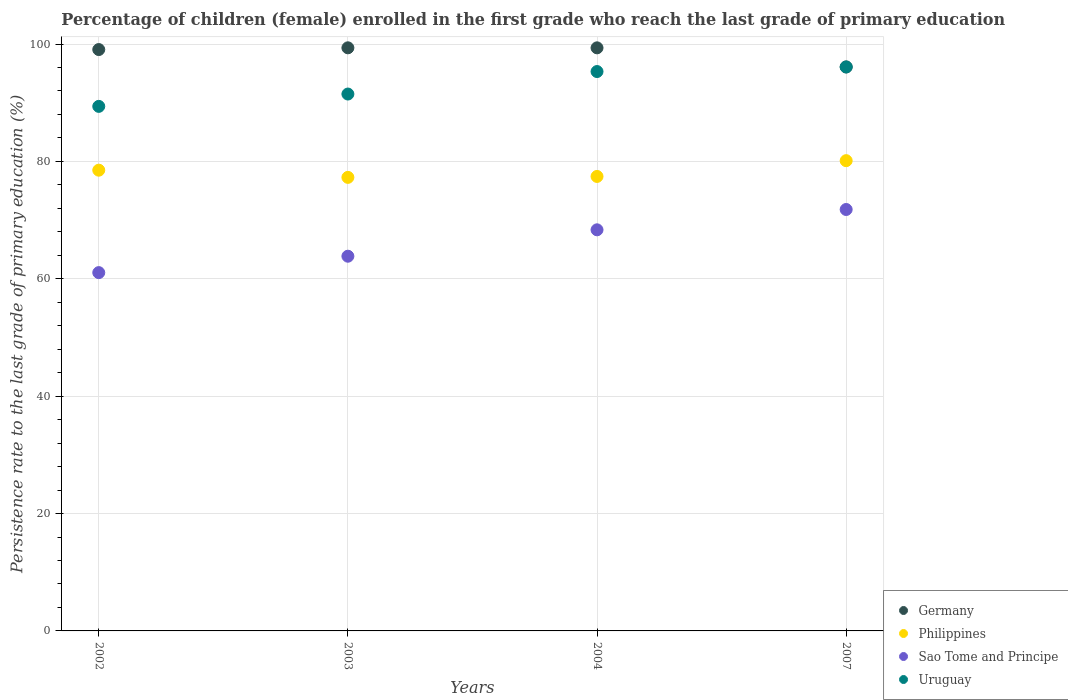What is the persistence rate of children in Germany in 2003?
Make the answer very short. 99.35. Across all years, what is the maximum persistence rate of children in Sao Tome and Principe?
Your response must be concise. 71.8. Across all years, what is the minimum persistence rate of children in Philippines?
Ensure brevity in your answer.  77.28. In which year was the persistence rate of children in Germany maximum?
Provide a short and direct response. 2003. What is the total persistence rate of children in Germany in the graph?
Your response must be concise. 393.84. What is the difference between the persistence rate of children in Sao Tome and Principe in 2002 and that in 2003?
Ensure brevity in your answer.  -2.8. What is the difference between the persistence rate of children in Sao Tome and Principe in 2003 and the persistence rate of children in Germany in 2007?
Your response must be concise. -32.24. What is the average persistence rate of children in Philippines per year?
Ensure brevity in your answer.  78.33. In the year 2004, what is the difference between the persistence rate of children in Philippines and persistence rate of children in Uruguay?
Keep it short and to the point. -17.87. What is the ratio of the persistence rate of children in Sao Tome and Principe in 2002 to that in 2003?
Provide a short and direct response. 0.96. Is the persistence rate of children in Sao Tome and Principe in 2002 less than that in 2007?
Offer a very short reply. Yes. Is the difference between the persistence rate of children in Philippines in 2002 and 2003 greater than the difference between the persistence rate of children in Uruguay in 2002 and 2003?
Your answer should be very brief. Yes. What is the difference between the highest and the second highest persistence rate of children in Germany?
Ensure brevity in your answer.  0. What is the difference between the highest and the lowest persistence rate of children in Uruguay?
Keep it short and to the point. 6.72. Is it the case that in every year, the sum of the persistence rate of children in Germany and persistence rate of children in Uruguay  is greater than the persistence rate of children in Sao Tome and Principe?
Offer a very short reply. Yes. Is the persistence rate of children in Uruguay strictly greater than the persistence rate of children in Germany over the years?
Ensure brevity in your answer.  No. How many years are there in the graph?
Provide a short and direct response. 4. What is the difference between two consecutive major ticks on the Y-axis?
Ensure brevity in your answer.  20. Does the graph contain grids?
Offer a very short reply. Yes. How many legend labels are there?
Offer a terse response. 4. What is the title of the graph?
Offer a terse response. Percentage of children (female) enrolled in the first grade who reach the last grade of primary education. What is the label or title of the X-axis?
Provide a short and direct response. Years. What is the label or title of the Y-axis?
Make the answer very short. Persistence rate to the last grade of primary education (%). What is the Persistence rate to the last grade of primary education (%) in Germany in 2002?
Make the answer very short. 99.05. What is the Persistence rate to the last grade of primary education (%) of Philippines in 2002?
Provide a succinct answer. 78.5. What is the Persistence rate to the last grade of primary education (%) in Sao Tome and Principe in 2002?
Your answer should be very brief. 61.05. What is the Persistence rate to the last grade of primary education (%) in Uruguay in 2002?
Keep it short and to the point. 89.37. What is the Persistence rate to the last grade of primary education (%) of Germany in 2003?
Ensure brevity in your answer.  99.35. What is the Persistence rate to the last grade of primary education (%) in Philippines in 2003?
Offer a terse response. 77.28. What is the Persistence rate to the last grade of primary education (%) of Sao Tome and Principe in 2003?
Offer a very short reply. 63.84. What is the Persistence rate to the last grade of primary education (%) of Uruguay in 2003?
Provide a short and direct response. 91.48. What is the Persistence rate to the last grade of primary education (%) of Germany in 2004?
Keep it short and to the point. 99.35. What is the Persistence rate to the last grade of primary education (%) in Philippines in 2004?
Offer a terse response. 77.44. What is the Persistence rate to the last grade of primary education (%) in Sao Tome and Principe in 2004?
Keep it short and to the point. 68.34. What is the Persistence rate to the last grade of primary education (%) in Uruguay in 2004?
Provide a short and direct response. 95.31. What is the Persistence rate to the last grade of primary education (%) in Germany in 2007?
Ensure brevity in your answer.  96.09. What is the Persistence rate to the last grade of primary education (%) in Philippines in 2007?
Provide a short and direct response. 80.12. What is the Persistence rate to the last grade of primary education (%) of Sao Tome and Principe in 2007?
Give a very brief answer. 71.8. What is the Persistence rate to the last grade of primary education (%) of Uruguay in 2007?
Keep it short and to the point. 96.09. Across all years, what is the maximum Persistence rate to the last grade of primary education (%) of Germany?
Your answer should be very brief. 99.35. Across all years, what is the maximum Persistence rate to the last grade of primary education (%) in Philippines?
Your answer should be compact. 80.12. Across all years, what is the maximum Persistence rate to the last grade of primary education (%) in Sao Tome and Principe?
Provide a succinct answer. 71.8. Across all years, what is the maximum Persistence rate to the last grade of primary education (%) in Uruguay?
Keep it short and to the point. 96.09. Across all years, what is the minimum Persistence rate to the last grade of primary education (%) of Germany?
Your answer should be compact. 96.09. Across all years, what is the minimum Persistence rate to the last grade of primary education (%) in Philippines?
Your answer should be compact. 77.28. Across all years, what is the minimum Persistence rate to the last grade of primary education (%) in Sao Tome and Principe?
Offer a terse response. 61.05. Across all years, what is the minimum Persistence rate to the last grade of primary education (%) in Uruguay?
Your answer should be very brief. 89.37. What is the total Persistence rate to the last grade of primary education (%) in Germany in the graph?
Offer a terse response. 393.84. What is the total Persistence rate to the last grade of primary education (%) of Philippines in the graph?
Your response must be concise. 313.34. What is the total Persistence rate to the last grade of primary education (%) in Sao Tome and Principe in the graph?
Ensure brevity in your answer.  265.04. What is the total Persistence rate to the last grade of primary education (%) of Uruguay in the graph?
Offer a terse response. 372.25. What is the difference between the Persistence rate to the last grade of primary education (%) of Germany in 2002 and that in 2003?
Your answer should be very brief. -0.3. What is the difference between the Persistence rate to the last grade of primary education (%) in Philippines in 2002 and that in 2003?
Your answer should be very brief. 1.23. What is the difference between the Persistence rate to the last grade of primary education (%) of Sao Tome and Principe in 2002 and that in 2003?
Offer a terse response. -2.8. What is the difference between the Persistence rate to the last grade of primary education (%) in Uruguay in 2002 and that in 2003?
Give a very brief answer. -2.1. What is the difference between the Persistence rate to the last grade of primary education (%) in Germany in 2002 and that in 2004?
Provide a short and direct response. -0.29. What is the difference between the Persistence rate to the last grade of primary education (%) of Philippines in 2002 and that in 2004?
Provide a succinct answer. 1.07. What is the difference between the Persistence rate to the last grade of primary education (%) of Sao Tome and Principe in 2002 and that in 2004?
Your response must be concise. -7.29. What is the difference between the Persistence rate to the last grade of primary education (%) in Uruguay in 2002 and that in 2004?
Provide a succinct answer. -5.93. What is the difference between the Persistence rate to the last grade of primary education (%) of Germany in 2002 and that in 2007?
Provide a succinct answer. 2.97. What is the difference between the Persistence rate to the last grade of primary education (%) of Philippines in 2002 and that in 2007?
Keep it short and to the point. -1.62. What is the difference between the Persistence rate to the last grade of primary education (%) of Sao Tome and Principe in 2002 and that in 2007?
Offer a very short reply. -10.76. What is the difference between the Persistence rate to the last grade of primary education (%) in Uruguay in 2002 and that in 2007?
Your answer should be very brief. -6.72. What is the difference between the Persistence rate to the last grade of primary education (%) of Germany in 2003 and that in 2004?
Your response must be concise. 0. What is the difference between the Persistence rate to the last grade of primary education (%) in Philippines in 2003 and that in 2004?
Make the answer very short. -0.16. What is the difference between the Persistence rate to the last grade of primary education (%) of Sao Tome and Principe in 2003 and that in 2004?
Ensure brevity in your answer.  -4.5. What is the difference between the Persistence rate to the last grade of primary education (%) of Uruguay in 2003 and that in 2004?
Offer a terse response. -3.83. What is the difference between the Persistence rate to the last grade of primary education (%) in Germany in 2003 and that in 2007?
Make the answer very short. 3.26. What is the difference between the Persistence rate to the last grade of primary education (%) in Philippines in 2003 and that in 2007?
Keep it short and to the point. -2.85. What is the difference between the Persistence rate to the last grade of primary education (%) in Sao Tome and Principe in 2003 and that in 2007?
Ensure brevity in your answer.  -7.96. What is the difference between the Persistence rate to the last grade of primary education (%) in Uruguay in 2003 and that in 2007?
Give a very brief answer. -4.62. What is the difference between the Persistence rate to the last grade of primary education (%) in Germany in 2004 and that in 2007?
Provide a succinct answer. 3.26. What is the difference between the Persistence rate to the last grade of primary education (%) in Philippines in 2004 and that in 2007?
Your answer should be very brief. -2.69. What is the difference between the Persistence rate to the last grade of primary education (%) of Sao Tome and Principe in 2004 and that in 2007?
Offer a very short reply. -3.46. What is the difference between the Persistence rate to the last grade of primary education (%) of Uruguay in 2004 and that in 2007?
Provide a succinct answer. -0.78. What is the difference between the Persistence rate to the last grade of primary education (%) of Germany in 2002 and the Persistence rate to the last grade of primary education (%) of Philippines in 2003?
Your answer should be compact. 21.78. What is the difference between the Persistence rate to the last grade of primary education (%) in Germany in 2002 and the Persistence rate to the last grade of primary education (%) in Sao Tome and Principe in 2003?
Make the answer very short. 35.21. What is the difference between the Persistence rate to the last grade of primary education (%) in Germany in 2002 and the Persistence rate to the last grade of primary education (%) in Uruguay in 2003?
Make the answer very short. 7.58. What is the difference between the Persistence rate to the last grade of primary education (%) of Philippines in 2002 and the Persistence rate to the last grade of primary education (%) of Sao Tome and Principe in 2003?
Keep it short and to the point. 14.66. What is the difference between the Persistence rate to the last grade of primary education (%) in Philippines in 2002 and the Persistence rate to the last grade of primary education (%) in Uruguay in 2003?
Keep it short and to the point. -12.97. What is the difference between the Persistence rate to the last grade of primary education (%) in Sao Tome and Principe in 2002 and the Persistence rate to the last grade of primary education (%) in Uruguay in 2003?
Make the answer very short. -30.43. What is the difference between the Persistence rate to the last grade of primary education (%) in Germany in 2002 and the Persistence rate to the last grade of primary education (%) in Philippines in 2004?
Your answer should be very brief. 21.62. What is the difference between the Persistence rate to the last grade of primary education (%) of Germany in 2002 and the Persistence rate to the last grade of primary education (%) of Sao Tome and Principe in 2004?
Offer a terse response. 30.71. What is the difference between the Persistence rate to the last grade of primary education (%) of Germany in 2002 and the Persistence rate to the last grade of primary education (%) of Uruguay in 2004?
Provide a succinct answer. 3.75. What is the difference between the Persistence rate to the last grade of primary education (%) of Philippines in 2002 and the Persistence rate to the last grade of primary education (%) of Sao Tome and Principe in 2004?
Provide a succinct answer. 10.16. What is the difference between the Persistence rate to the last grade of primary education (%) of Philippines in 2002 and the Persistence rate to the last grade of primary education (%) of Uruguay in 2004?
Provide a short and direct response. -16.81. What is the difference between the Persistence rate to the last grade of primary education (%) of Sao Tome and Principe in 2002 and the Persistence rate to the last grade of primary education (%) of Uruguay in 2004?
Ensure brevity in your answer.  -34.26. What is the difference between the Persistence rate to the last grade of primary education (%) in Germany in 2002 and the Persistence rate to the last grade of primary education (%) in Philippines in 2007?
Give a very brief answer. 18.93. What is the difference between the Persistence rate to the last grade of primary education (%) in Germany in 2002 and the Persistence rate to the last grade of primary education (%) in Sao Tome and Principe in 2007?
Your answer should be compact. 27.25. What is the difference between the Persistence rate to the last grade of primary education (%) in Germany in 2002 and the Persistence rate to the last grade of primary education (%) in Uruguay in 2007?
Ensure brevity in your answer.  2.96. What is the difference between the Persistence rate to the last grade of primary education (%) of Philippines in 2002 and the Persistence rate to the last grade of primary education (%) of Sao Tome and Principe in 2007?
Ensure brevity in your answer.  6.7. What is the difference between the Persistence rate to the last grade of primary education (%) in Philippines in 2002 and the Persistence rate to the last grade of primary education (%) in Uruguay in 2007?
Give a very brief answer. -17.59. What is the difference between the Persistence rate to the last grade of primary education (%) of Sao Tome and Principe in 2002 and the Persistence rate to the last grade of primary education (%) of Uruguay in 2007?
Provide a short and direct response. -35.04. What is the difference between the Persistence rate to the last grade of primary education (%) of Germany in 2003 and the Persistence rate to the last grade of primary education (%) of Philippines in 2004?
Provide a succinct answer. 21.92. What is the difference between the Persistence rate to the last grade of primary education (%) of Germany in 2003 and the Persistence rate to the last grade of primary education (%) of Sao Tome and Principe in 2004?
Your response must be concise. 31.01. What is the difference between the Persistence rate to the last grade of primary education (%) in Germany in 2003 and the Persistence rate to the last grade of primary education (%) in Uruguay in 2004?
Give a very brief answer. 4.04. What is the difference between the Persistence rate to the last grade of primary education (%) in Philippines in 2003 and the Persistence rate to the last grade of primary education (%) in Sao Tome and Principe in 2004?
Offer a terse response. 8.94. What is the difference between the Persistence rate to the last grade of primary education (%) of Philippines in 2003 and the Persistence rate to the last grade of primary education (%) of Uruguay in 2004?
Your answer should be very brief. -18.03. What is the difference between the Persistence rate to the last grade of primary education (%) in Sao Tome and Principe in 2003 and the Persistence rate to the last grade of primary education (%) in Uruguay in 2004?
Give a very brief answer. -31.46. What is the difference between the Persistence rate to the last grade of primary education (%) in Germany in 2003 and the Persistence rate to the last grade of primary education (%) in Philippines in 2007?
Give a very brief answer. 19.23. What is the difference between the Persistence rate to the last grade of primary education (%) of Germany in 2003 and the Persistence rate to the last grade of primary education (%) of Sao Tome and Principe in 2007?
Make the answer very short. 27.55. What is the difference between the Persistence rate to the last grade of primary education (%) of Germany in 2003 and the Persistence rate to the last grade of primary education (%) of Uruguay in 2007?
Your answer should be compact. 3.26. What is the difference between the Persistence rate to the last grade of primary education (%) of Philippines in 2003 and the Persistence rate to the last grade of primary education (%) of Sao Tome and Principe in 2007?
Offer a very short reply. 5.47. What is the difference between the Persistence rate to the last grade of primary education (%) in Philippines in 2003 and the Persistence rate to the last grade of primary education (%) in Uruguay in 2007?
Offer a terse response. -18.81. What is the difference between the Persistence rate to the last grade of primary education (%) in Sao Tome and Principe in 2003 and the Persistence rate to the last grade of primary education (%) in Uruguay in 2007?
Give a very brief answer. -32.25. What is the difference between the Persistence rate to the last grade of primary education (%) in Germany in 2004 and the Persistence rate to the last grade of primary education (%) in Philippines in 2007?
Ensure brevity in your answer.  19.22. What is the difference between the Persistence rate to the last grade of primary education (%) in Germany in 2004 and the Persistence rate to the last grade of primary education (%) in Sao Tome and Principe in 2007?
Give a very brief answer. 27.54. What is the difference between the Persistence rate to the last grade of primary education (%) in Germany in 2004 and the Persistence rate to the last grade of primary education (%) in Uruguay in 2007?
Provide a short and direct response. 3.26. What is the difference between the Persistence rate to the last grade of primary education (%) in Philippines in 2004 and the Persistence rate to the last grade of primary education (%) in Sao Tome and Principe in 2007?
Your answer should be compact. 5.63. What is the difference between the Persistence rate to the last grade of primary education (%) in Philippines in 2004 and the Persistence rate to the last grade of primary education (%) in Uruguay in 2007?
Your response must be concise. -18.65. What is the difference between the Persistence rate to the last grade of primary education (%) in Sao Tome and Principe in 2004 and the Persistence rate to the last grade of primary education (%) in Uruguay in 2007?
Your response must be concise. -27.75. What is the average Persistence rate to the last grade of primary education (%) in Germany per year?
Offer a very short reply. 98.46. What is the average Persistence rate to the last grade of primary education (%) in Philippines per year?
Keep it short and to the point. 78.33. What is the average Persistence rate to the last grade of primary education (%) of Sao Tome and Principe per year?
Offer a terse response. 66.26. What is the average Persistence rate to the last grade of primary education (%) in Uruguay per year?
Provide a short and direct response. 93.06. In the year 2002, what is the difference between the Persistence rate to the last grade of primary education (%) in Germany and Persistence rate to the last grade of primary education (%) in Philippines?
Offer a terse response. 20.55. In the year 2002, what is the difference between the Persistence rate to the last grade of primary education (%) in Germany and Persistence rate to the last grade of primary education (%) in Sao Tome and Principe?
Provide a succinct answer. 38.01. In the year 2002, what is the difference between the Persistence rate to the last grade of primary education (%) of Germany and Persistence rate to the last grade of primary education (%) of Uruguay?
Provide a short and direct response. 9.68. In the year 2002, what is the difference between the Persistence rate to the last grade of primary education (%) of Philippines and Persistence rate to the last grade of primary education (%) of Sao Tome and Principe?
Offer a very short reply. 17.45. In the year 2002, what is the difference between the Persistence rate to the last grade of primary education (%) in Philippines and Persistence rate to the last grade of primary education (%) in Uruguay?
Provide a short and direct response. -10.87. In the year 2002, what is the difference between the Persistence rate to the last grade of primary education (%) of Sao Tome and Principe and Persistence rate to the last grade of primary education (%) of Uruguay?
Keep it short and to the point. -28.32. In the year 2003, what is the difference between the Persistence rate to the last grade of primary education (%) of Germany and Persistence rate to the last grade of primary education (%) of Philippines?
Provide a short and direct response. 22.07. In the year 2003, what is the difference between the Persistence rate to the last grade of primary education (%) in Germany and Persistence rate to the last grade of primary education (%) in Sao Tome and Principe?
Keep it short and to the point. 35.51. In the year 2003, what is the difference between the Persistence rate to the last grade of primary education (%) in Germany and Persistence rate to the last grade of primary education (%) in Uruguay?
Keep it short and to the point. 7.88. In the year 2003, what is the difference between the Persistence rate to the last grade of primary education (%) in Philippines and Persistence rate to the last grade of primary education (%) in Sao Tome and Principe?
Your response must be concise. 13.43. In the year 2003, what is the difference between the Persistence rate to the last grade of primary education (%) in Philippines and Persistence rate to the last grade of primary education (%) in Uruguay?
Your answer should be very brief. -14.2. In the year 2003, what is the difference between the Persistence rate to the last grade of primary education (%) of Sao Tome and Principe and Persistence rate to the last grade of primary education (%) of Uruguay?
Offer a very short reply. -27.63. In the year 2004, what is the difference between the Persistence rate to the last grade of primary education (%) of Germany and Persistence rate to the last grade of primary education (%) of Philippines?
Ensure brevity in your answer.  21.91. In the year 2004, what is the difference between the Persistence rate to the last grade of primary education (%) of Germany and Persistence rate to the last grade of primary education (%) of Sao Tome and Principe?
Provide a succinct answer. 31.01. In the year 2004, what is the difference between the Persistence rate to the last grade of primary education (%) of Germany and Persistence rate to the last grade of primary education (%) of Uruguay?
Offer a very short reply. 4.04. In the year 2004, what is the difference between the Persistence rate to the last grade of primary education (%) of Philippines and Persistence rate to the last grade of primary education (%) of Sao Tome and Principe?
Keep it short and to the point. 9.09. In the year 2004, what is the difference between the Persistence rate to the last grade of primary education (%) of Philippines and Persistence rate to the last grade of primary education (%) of Uruguay?
Make the answer very short. -17.87. In the year 2004, what is the difference between the Persistence rate to the last grade of primary education (%) of Sao Tome and Principe and Persistence rate to the last grade of primary education (%) of Uruguay?
Make the answer very short. -26.97. In the year 2007, what is the difference between the Persistence rate to the last grade of primary education (%) in Germany and Persistence rate to the last grade of primary education (%) in Philippines?
Your response must be concise. 15.97. In the year 2007, what is the difference between the Persistence rate to the last grade of primary education (%) in Germany and Persistence rate to the last grade of primary education (%) in Sao Tome and Principe?
Your response must be concise. 24.28. In the year 2007, what is the difference between the Persistence rate to the last grade of primary education (%) of Germany and Persistence rate to the last grade of primary education (%) of Uruguay?
Offer a terse response. -0. In the year 2007, what is the difference between the Persistence rate to the last grade of primary education (%) in Philippines and Persistence rate to the last grade of primary education (%) in Sao Tome and Principe?
Your answer should be compact. 8.32. In the year 2007, what is the difference between the Persistence rate to the last grade of primary education (%) in Philippines and Persistence rate to the last grade of primary education (%) in Uruguay?
Provide a short and direct response. -15.97. In the year 2007, what is the difference between the Persistence rate to the last grade of primary education (%) of Sao Tome and Principe and Persistence rate to the last grade of primary education (%) of Uruguay?
Keep it short and to the point. -24.29. What is the ratio of the Persistence rate to the last grade of primary education (%) in Philippines in 2002 to that in 2003?
Your response must be concise. 1.02. What is the ratio of the Persistence rate to the last grade of primary education (%) in Sao Tome and Principe in 2002 to that in 2003?
Make the answer very short. 0.96. What is the ratio of the Persistence rate to the last grade of primary education (%) in Uruguay in 2002 to that in 2003?
Provide a short and direct response. 0.98. What is the ratio of the Persistence rate to the last grade of primary education (%) of Philippines in 2002 to that in 2004?
Your response must be concise. 1.01. What is the ratio of the Persistence rate to the last grade of primary education (%) of Sao Tome and Principe in 2002 to that in 2004?
Provide a short and direct response. 0.89. What is the ratio of the Persistence rate to the last grade of primary education (%) of Uruguay in 2002 to that in 2004?
Offer a terse response. 0.94. What is the ratio of the Persistence rate to the last grade of primary education (%) in Germany in 2002 to that in 2007?
Ensure brevity in your answer.  1.03. What is the ratio of the Persistence rate to the last grade of primary education (%) of Philippines in 2002 to that in 2007?
Make the answer very short. 0.98. What is the ratio of the Persistence rate to the last grade of primary education (%) in Sao Tome and Principe in 2002 to that in 2007?
Your answer should be very brief. 0.85. What is the ratio of the Persistence rate to the last grade of primary education (%) of Uruguay in 2002 to that in 2007?
Make the answer very short. 0.93. What is the ratio of the Persistence rate to the last grade of primary education (%) in Germany in 2003 to that in 2004?
Your answer should be compact. 1. What is the ratio of the Persistence rate to the last grade of primary education (%) of Philippines in 2003 to that in 2004?
Your response must be concise. 1. What is the ratio of the Persistence rate to the last grade of primary education (%) in Sao Tome and Principe in 2003 to that in 2004?
Your answer should be very brief. 0.93. What is the ratio of the Persistence rate to the last grade of primary education (%) of Uruguay in 2003 to that in 2004?
Your answer should be compact. 0.96. What is the ratio of the Persistence rate to the last grade of primary education (%) in Germany in 2003 to that in 2007?
Provide a succinct answer. 1.03. What is the ratio of the Persistence rate to the last grade of primary education (%) in Philippines in 2003 to that in 2007?
Make the answer very short. 0.96. What is the ratio of the Persistence rate to the last grade of primary education (%) of Sao Tome and Principe in 2003 to that in 2007?
Your answer should be very brief. 0.89. What is the ratio of the Persistence rate to the last grade of primary education (%) in Germany in 2004 to that in 2007?
Provide a succinct answer. 1.03. What is the ratio of the Persistence rate to the last grade of primary education (%) in Philippines in 2004 to that in 2007?
Give a very brief answer. 0.97. What is the ratio of the Persistence rate to the last grade of primary education (%) of Sao Tome and Principe in 2004 to that in 2007?
Your answer should be compact. 0.95. What is the ratio of the Persistence rate to the last grade of primary education (%) in Uruguay in 2004 to that in 2007?
Your answer should be compact. 0.99. What is the difference between the highest and the second highest Persistence rate to the last grade of primary education (%) of Germany?
Give a very brief answer. 0. What is the difference between the highest and the second highest Persistence rate to the last grade of primary education (%) of Philippines?
Offer a very short reply. 1.62. What is the difference between the highest and the second highest Persistence rate to the last grade of primary education (%) of Sao Tome and Principe?
Provide a succinct answer. 3.46. What is the difference between the highest and the second highest Persistence rate to the last grade of primary education (%) of Uruguay?
Give a very brief answer. 0.78. What is the difference between the highest and the lowest Persistence rate to the last grade of primary education (%) in Germany?
Keep it short and to the point. 3.26. What is the difference between the highest and the lowest Persistence rate to the last grade of primary education (%) of Philippines?
Provide a succinct answer. 2.85. What is the difference between the highest and the lowest Persistence rate to the last grade of primary education (%) of Sao Tome and Principe?
Make the answer very short. 10.76. What is the difference between the highest and the lowest Persistence rate to the last grade of primary education (%) of Uruguay?
Provide a short and direct response. 6.72. 